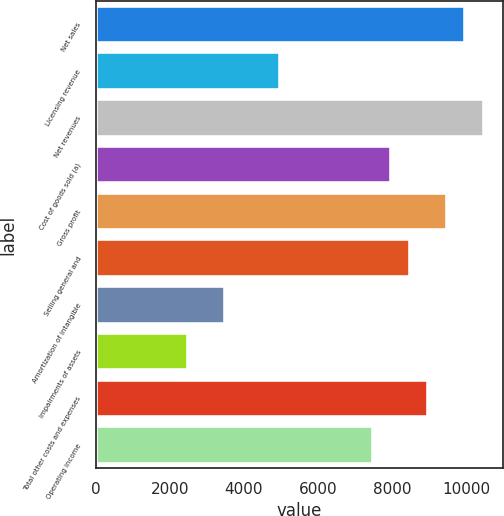Convert chart to OTSL. <chart><loc_0><loc_0><loc_500><loc_500><bar_chart><fcel>Net sales<fcel>Licensing revenue<fcel>Net revenues<fcel>Cost of goods sold (a)<fcel>Gross profit<fcel>Selling general and<fcel>Amortization of intangible<fcel>Impairments of assets<fcel>Total other costs and expenses<fcel>Operating income<nl><fcel>9957.5<fcel>4978.9<fcel>10455.4<fcel>7966.06<fcel>9459.64<fcel>8463.92<fcel>3485.32<fcel>2489.6<fcel>8961.78<fcel>7468.2<nl></chart> 